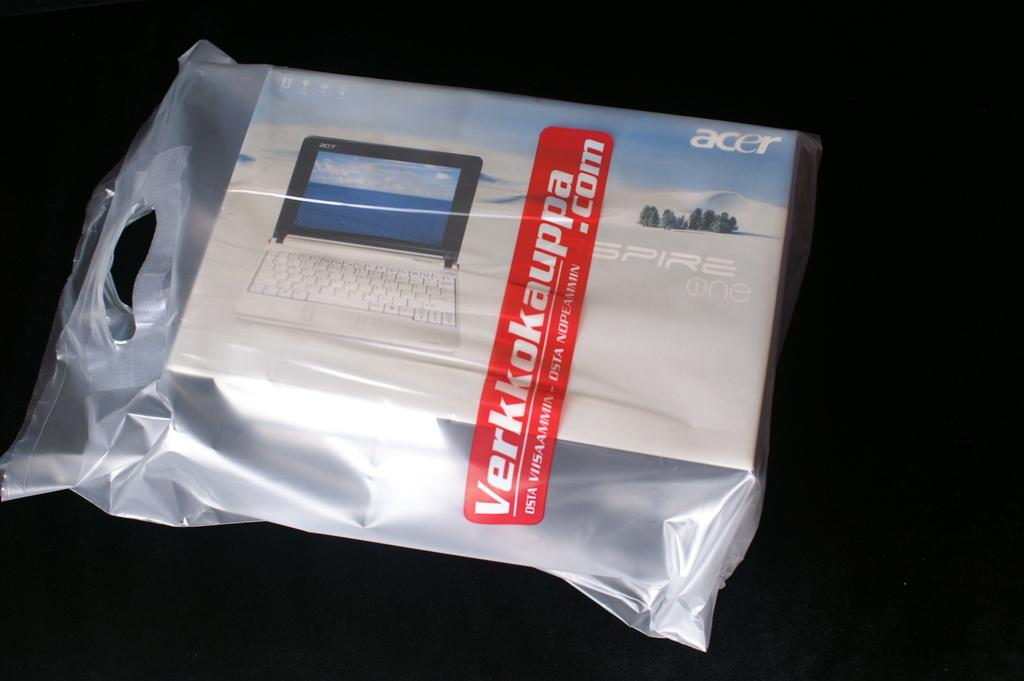What is contained within the packet in the image? There is a box inside the packet in the image. Can you describe the box? The box is white and blue in color, and there is a print of a laptop on it. What is the color of the surface on which the box is placed? The box is on a black color surface. What type of nation is depicted on the box? There is no depiction of a nation on the box; it features a print of a laptop. How many twigs are present in the image? There are no twigs present in the image. 